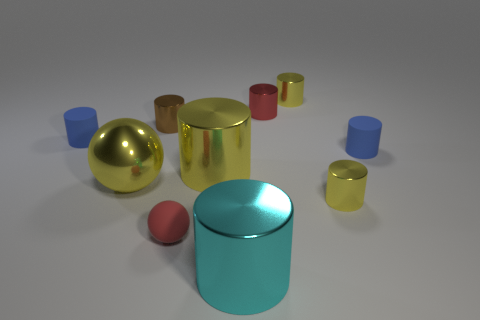How many yellow cylinders must be subtracted to get 1 yellow cylinders? 2 Subtract all red spheres. How many yellow cylinders are left? 3 Subtract all cyan cylinders. How many cylinders are left? 7 Subtract all small yellow cylinders. How many cylinders are left? 6 Subtract 3 cylinders. How many cylinders are left? 5 Subtract all blue cylinders. Subtract all gray cubes. How many cylinders are left? 6 Subtract all spheres. How many objects are left? 8 Subtract 1 blue cylinders. How many objects are left? 9 Subtract all tiny purple rubber spheres. Subtract all small blue objects. How many objects are left? 8 Add 9 big yellow cylinders. How many big yellow cylinders are left? 10 